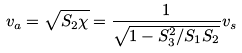<formula> <loc_0><loc_0><loc_500><loc_500>v _ { a } = \sqrt { S _ { 2 } \chi } = \frac { 1 } { \sqrt { 1 - S _ { 3 } ^ { 2 } / S _ { 1 } S _ { 2 } } } v _ { s } \,</formula> 